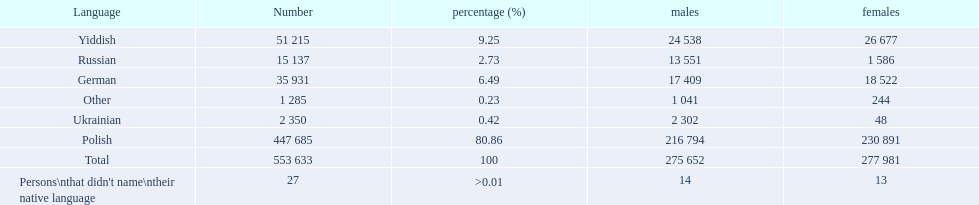What language makes a majority Polish. What the the total number of speakers? 553 633. 